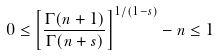<formula> <loc_0><loc_0><loc_500><loc_500>0 \leq \left [ \frac { \Gamma ( n + 1 ) } { \Gamma ( n + s ) } \right ] ^ { 1 / ( 1 - s ) } - n \leq 1</formula> 